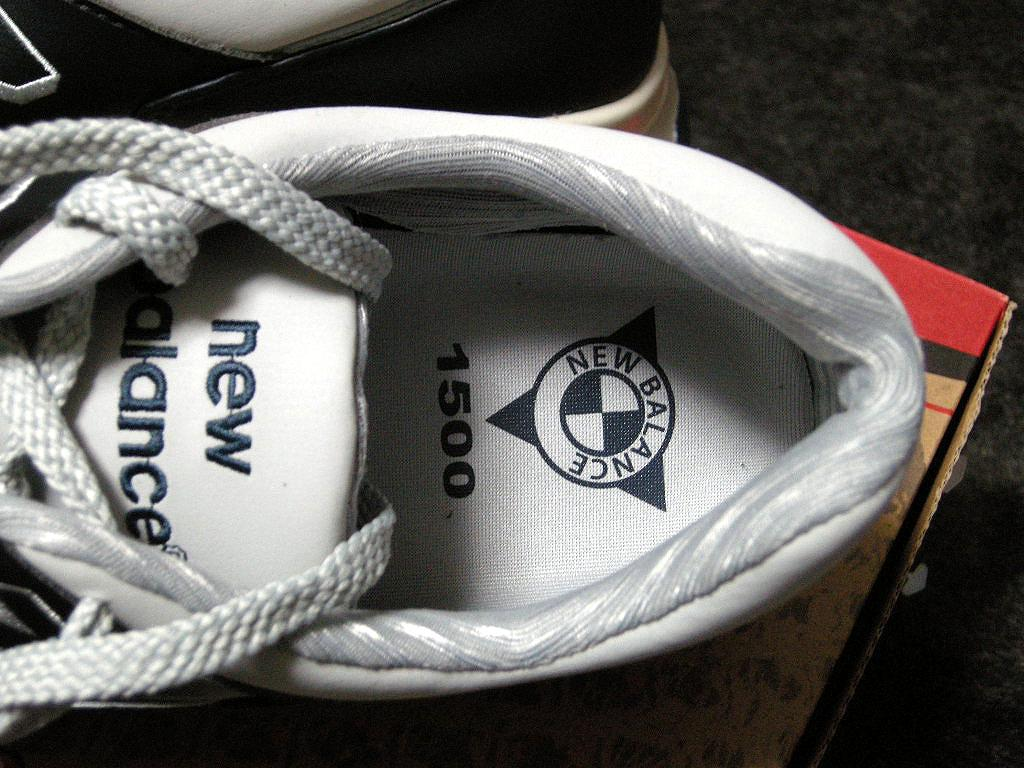What is placed on the cardboard box in the image? There is a shoe on a cardboard box in the image. Can you describe the other shoe in the image? There is another shoe on an object in the image. What thought is expressed by the shoe on the cardboard box in the image? Shoes do not express thoughts, so this question cannot be answered. 